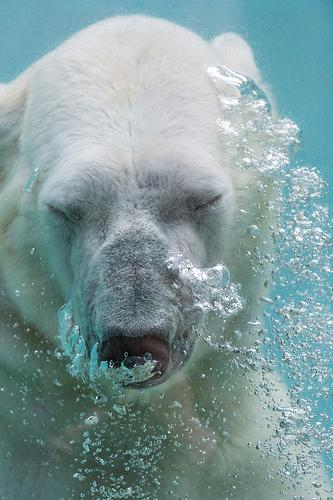Question: what is the dog doing?
Choices:
A. Eating.
B. Swimming.
C. Sleeping.
D. Playing.
Answer with the letter. Answer: B Question: when was the picture taken?
Choices:
A. Midnight.
B. Noon.
C. Sunset.
D. Daytime.
Answer with the letter. Answer: D Question: how are the dog's eyes?
Choices:
A. Open.
B. Closed.
C. Swollen.
D. Pink.
Answer with the letter. Answer: B 